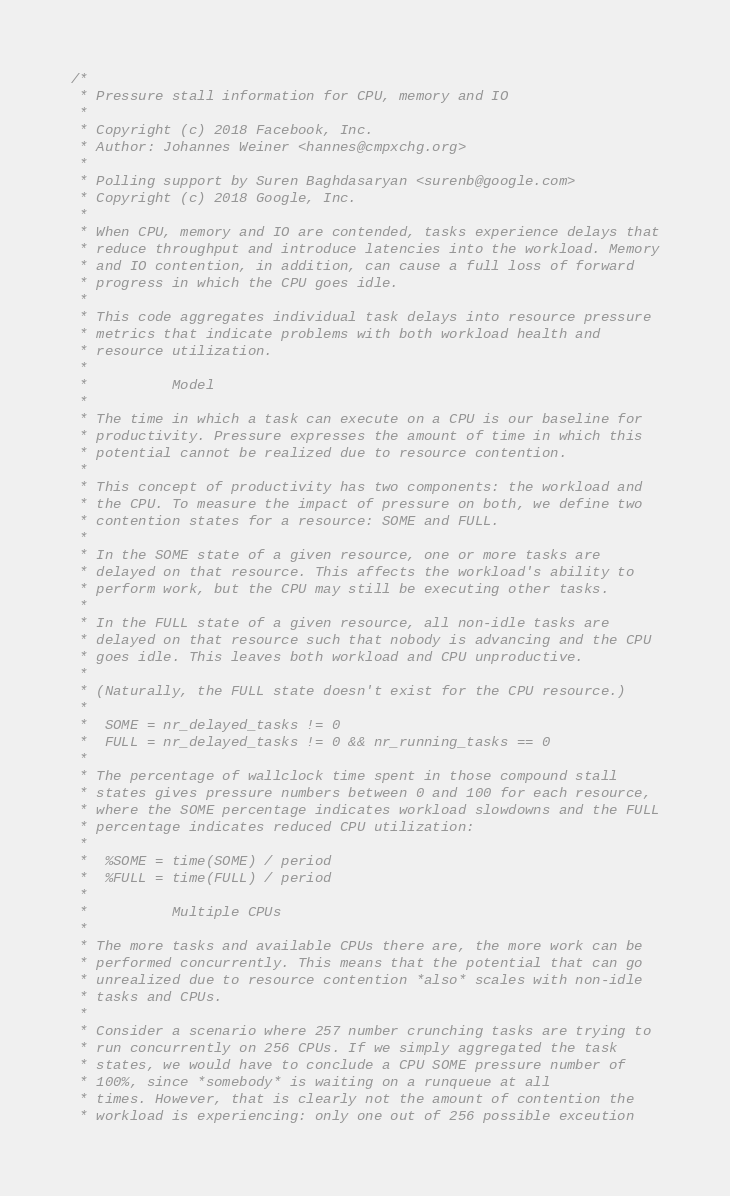<code> <loc_0><loc_0><loc_500><loc_500><_C_>/*
 * Pressure stall information for CPU, memory and IO
 *
 * Copyright (c) 2018 Facebook, Inc.
 * Author: Johannes Weiner <hannes@cmpxchg.org>
 *
 * Polling support by Suren Baghdasaryan <surenb@google.com>
 * Copyright (c) 2018 Google, Inc.
 *
 * When CPU, memory and IO are contended, tasks experience delays that
 * reduce throughput and introduce latencies into the workload. Memory
 * and IO contention, in addition, can cause a full loss of forward
 * progress in which the CPU goes idle.
 *
 * This code aggregates individual task delays into resource pressure
 * metrics that indicate problems with both workload health and
 * resource utilization.
 *
 *			Model
 *
 * The time in which a task can execute on a CPU is our baseline for
 * productivity. Pressure expresses the amount of time in which this
 * potential cannot be realized due to resource contention.
 *
 * This concept of productivity has two components: the workload and
 * the CPU. To measure the impact of pressure on both, we define two
 * contention states for a resource: SOME and FULL.
 *
 * In the SOME state of a given resource, one or more tasks are
 * delayed on that resource. This affects the workload's ability to
 * perform work, but the CPU may still be executing other tasks.
 *
 * In the FULL state of a given resource, all non-idle tasks are
 * delayed on that resource such that nobody is advancing and the CPU
 * goes idle. This leaves both workload and CPU unproductive.
 *
 * (Naturally, the FULL state doesn't exist for the CPU resource.)
 *
 *	SOME = nr_delayed_tasks != 0
 *	FULL = nr_delayed_tasks != 0 && nr_running_tasks == 0
 *
 * The percentage of wallclock time spent in those compound stall
 * states gives pressure numbers between 0 and 100 for each resource,
 * where the SOME percentage indicates workload slowdowns and the FULL
 * percentage indicates reduced CPU utilization:
 *
 *	%SOME = time(SOME) / period
 *	%FULL = time(FULL) / period
 *
 *			Multiple CPUs
 *
 * The more tasks and available CPUs there are, the more work can be
 * performed concurrently. This means that the potential that can go
 * unrealized due to resource contention *also* scales with non-idle
 * tasks and CPUs.
 *
 * Consider a scenario where 257 number crunching tasks are trying to
 * run concurrently on 256 CPUs. If we simply aggregated the task
 * states, we would have to conclude a CPU SOME pressure number of
 * 100%, since *somebody* is waiting on a runqueue at all
 * times. However, that is clearly not the amount of contention the
 * workload is experiencing: only one out of 256 possible exceution</code> 